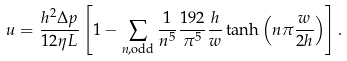Convert formula to latex. <formula><loc_0><loc_0><loc_500><loc_500>u = \frac { h ^ { 2 } \Delta p } { 1 2 \eta L } \left [ 1 - \sum _ { n , \text {odd} } \frac { 1 } { n ^ { 5 } } \frac { 1 9 2 } { \pi ^ { 5 } } \frac { h } { w } \tanh \left ( n \pi \frac { w } { 2 h } \right ) \right ] .</formula> 